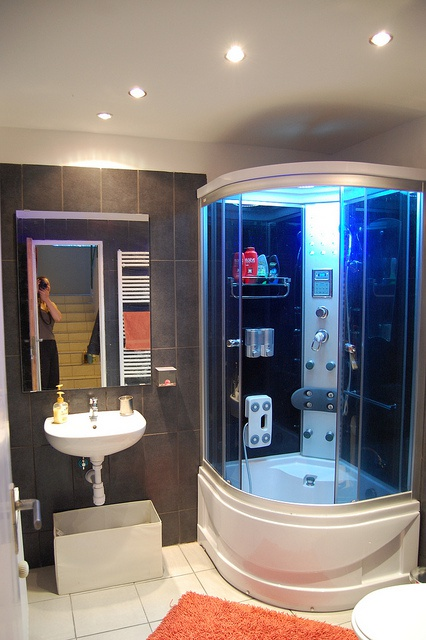Describe the objects in this image and their specific colors. I can see sink in gray, white, tan, and darkgray tones, toilet in gray, white, beige, and tan tones, people in gray, black, maroon, and brown tones, bottle in gray, brown, and purple tones, and bottle in gray, khaki, lightyellow, gold, and tan tones in this image. 